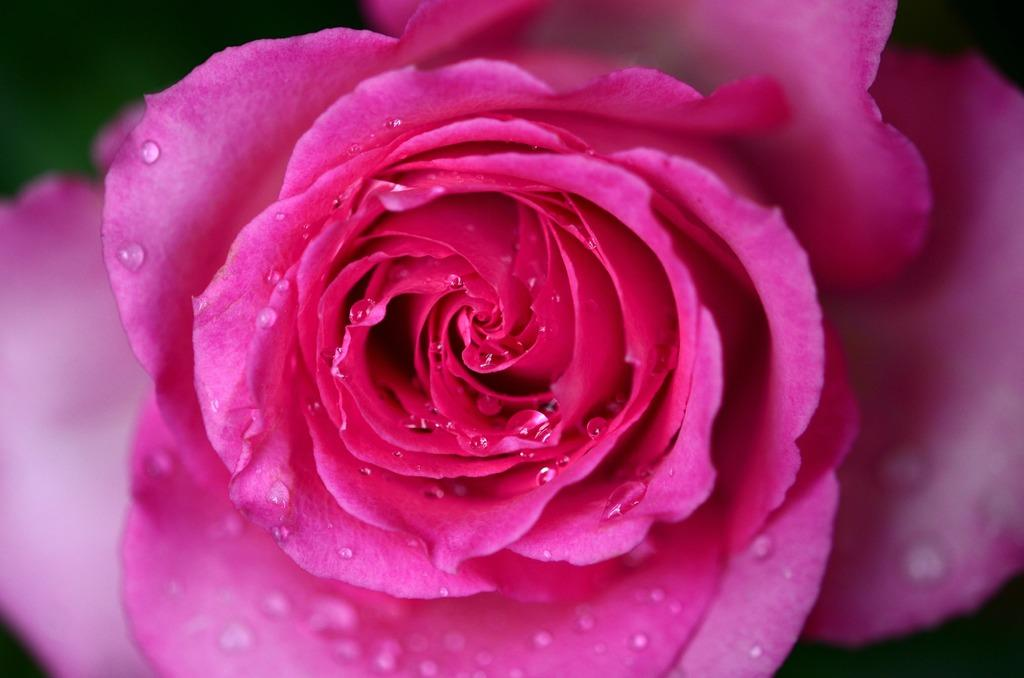What type of flower is in the image? There is a rose flower in the image. Can you describe the appearance of the rose flower? The rose flower has water droplets on it. What can be observed about the background of the image? The background of the image is blurred. How many cherries are hanging from the alarm in the image? There are no cherries or alarms present in the image; it features a rose flower with water droplets and a blurred background. 